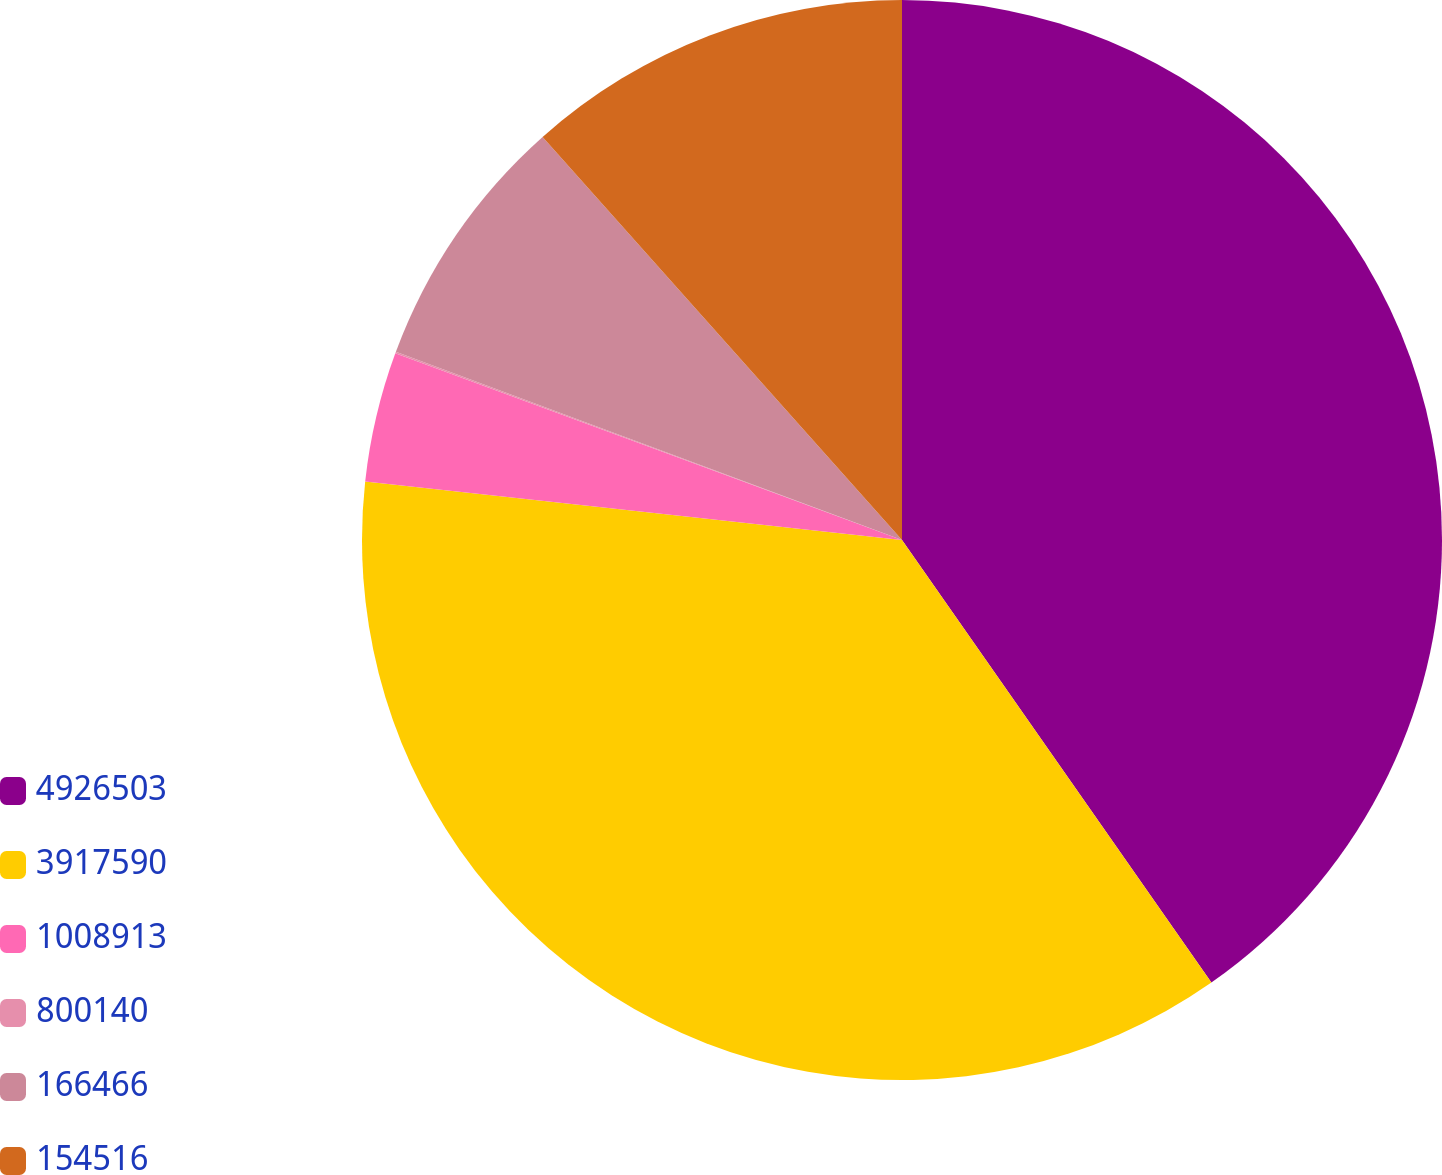<chart> <loc_0><loc_0><loc_500><loc_500><pie_chart><fcel>4926503<fcel>3917590<fcel>1008913<fcel>800140<fcel>166466<fcel>154516<nl><fcel>40.29%<fcel>36.44%<fcel>3.89%<fcel>0.05%<fcel>7.74%<fcel>11.59%<nl></chart> 